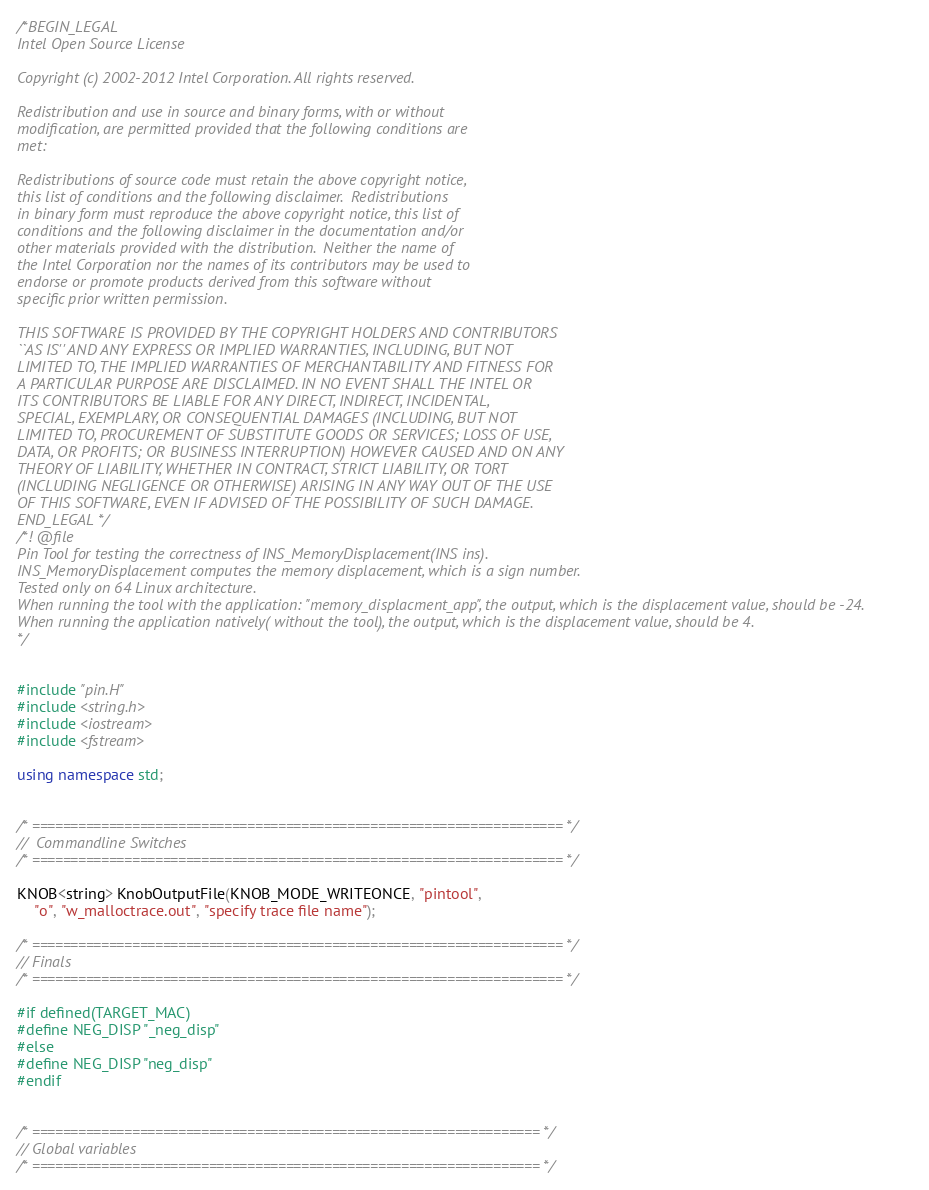Convert code to text. <code><loc_0><loc_0><loc_500><loc_500><_C++_>/*BEGIN_LEGAL 
Intel Open Source License 

Copyright (c) 2002-2012 Intel Corporation. All rights reserved.
 
Redistribution and use in source and binary forms, with or without
modification, are permitted provided that the following conditions are
met:

Redistributions of source code must retain the above copyright notice,
this list of conditions and the following disclaimer.  Redistributions
in binary form must reproduce the above copyright notice, this list of
conditions and the following disclaimer in the documentation and/or
other materials provided with the distribution.  Neither the name of
the Intel Corporation nor the names of its contributors may be used to
endorse or promote products derived from this software without
specific prior written permission.
 
THIS SOFTWARE IS PROVIDED BY THE COPYRIGHT HOLDERS AND CONTRIBUTORS
``AS IS'' AND ANY EXPRESS OR IMPLIED WARRANTIES, INCLUDING, BUT NOT
LIMITED TO, THE IMPLIED WARRANTIES OF MERCHANTABILITY AND FITNESS FOR
A PARTICULAR PURPOSE ARE DISCLAIMED. IN NO EVENT SHALL THE INTEL OR
ITS CONTRIBUTORS BE LIABLE FOR ANY DIRECT, INDIRECT, INCIDENTAL,
SPECIAL, EXEMPLARY, OR CONSEQUENTIAL DAMAGES (INCLUDING, BUT NOT
LIMITED TO, PROCUREMENT OF SUBSTITUTE GOODS OR SERVICES; LOSS OF USE,
DATA, OR PROFITS; OR BUSINESS INTERRUPTION) HOWEVER CAUSED AND ON ANY
THEORY OF LIABILITY, WHETHER IN CONTRACT, STRICT LIABILITY, OR TORT
(INCLUDING NEGLIGENCE OR OTHERWISE) ARISING IN ANY WAY OUT OF THE USE
OF THIS SOFTWARE, EVEN IF ADVISED OF THE POSSIBILITY OF SUCH DAMAGE.
END_LEGAL */
/*! @file
Pin Tool for testing the correctness of INS_MemoryDisplacement(INS ins).
INS_MemoryDisplacement computes the memory displacement, which is a sign number. 
Tested only on 64 Linux architecture.
When running the tool with the application: "memory_displacment_app", the output, which is the displacement value, should be -24.
When running the application natively( without the tool), the output, which is the displacement value, should be 4.
*/


#include "pin.H"
#include <string.h>
#include <iostream>
#include <fstream>

using namespace std;


/* ===================================================================== */
//  Commandline Switches 
/* ===================================================================== */

KNOB<string> KnobOutputFile(KNOB_MODE_WRITEONCE, "pintool",
	"o", "w_malloctrace.out", "specify trace file name");

/* ===================================================================== */
// Finals
/* ===================================================================== */

#if defined(TARGET_MAC)
#define NEG_DISP "_neg_disp"
#else
#define NEG_DISP "neg_disp"
#endif


/* ================================================================== */
// Global variables 
/* ================================================================== */
</code> 